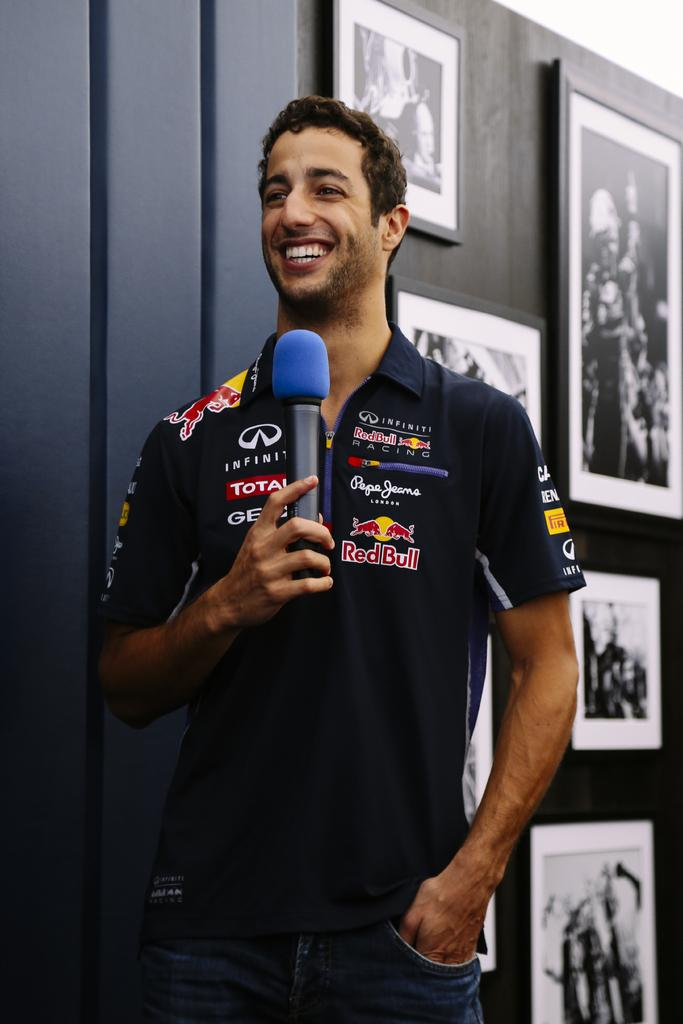<image>
Relay a brief, clear account of the picture shown. A man's collared shirt acknowledges a lot of sponsors including Red Bull. 